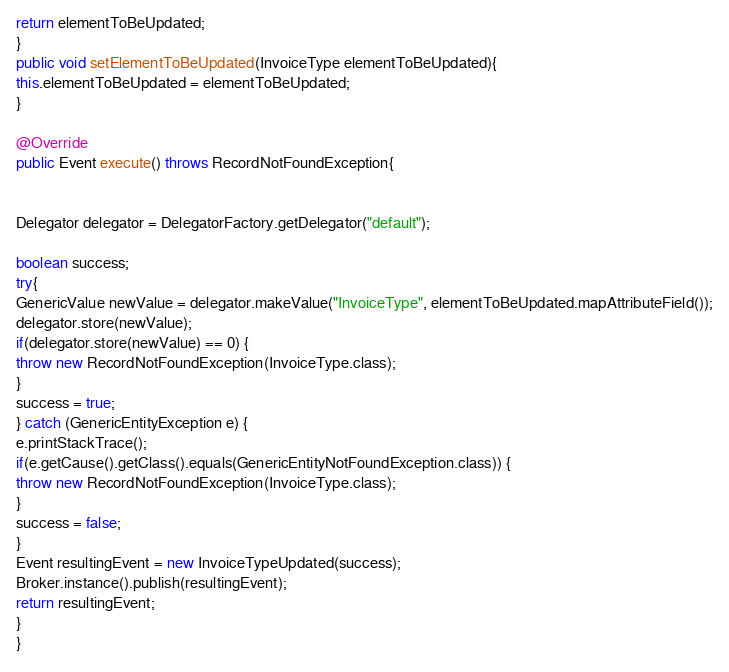<code> <loc_0><loc_0><loc_500><loc_500><_Java_>return elementToBeUpdated;
}
public void setElementToBeUpdated(InvoiceType elementToBeUpdated){
this.elementToBeUpdated = elementToBeUpdated;
}

@Override
public Event execute() throws RecordNotFoundException{


Delegator delegator = DelegatorFactory.getDelegator("default");

boolean success;
try{
GenericValue newValue = delegator.makeValue("InvoiceType", elementToBeUpdated.mapAttributeField());
delegator.store(newValue);
if(delegator.store(newValue) == 0) { 
throw new RecordNotFoundException(InvoiceType.class); 
}
success = true;
} catch (GenericEntityException e) {
e.printStackTrace();
if(e.getCause().getClass().equals(GenericEntityNotFoundException.class)) {
throw new RecordNotFoundException(InvoiceType.class);
}
success = false;
}
Event resultingEvent = new InvoiceTypeUpdated(success);
Broker.instance().publish(resultingEvent);
return resultingEvent;
}
}
</code> 